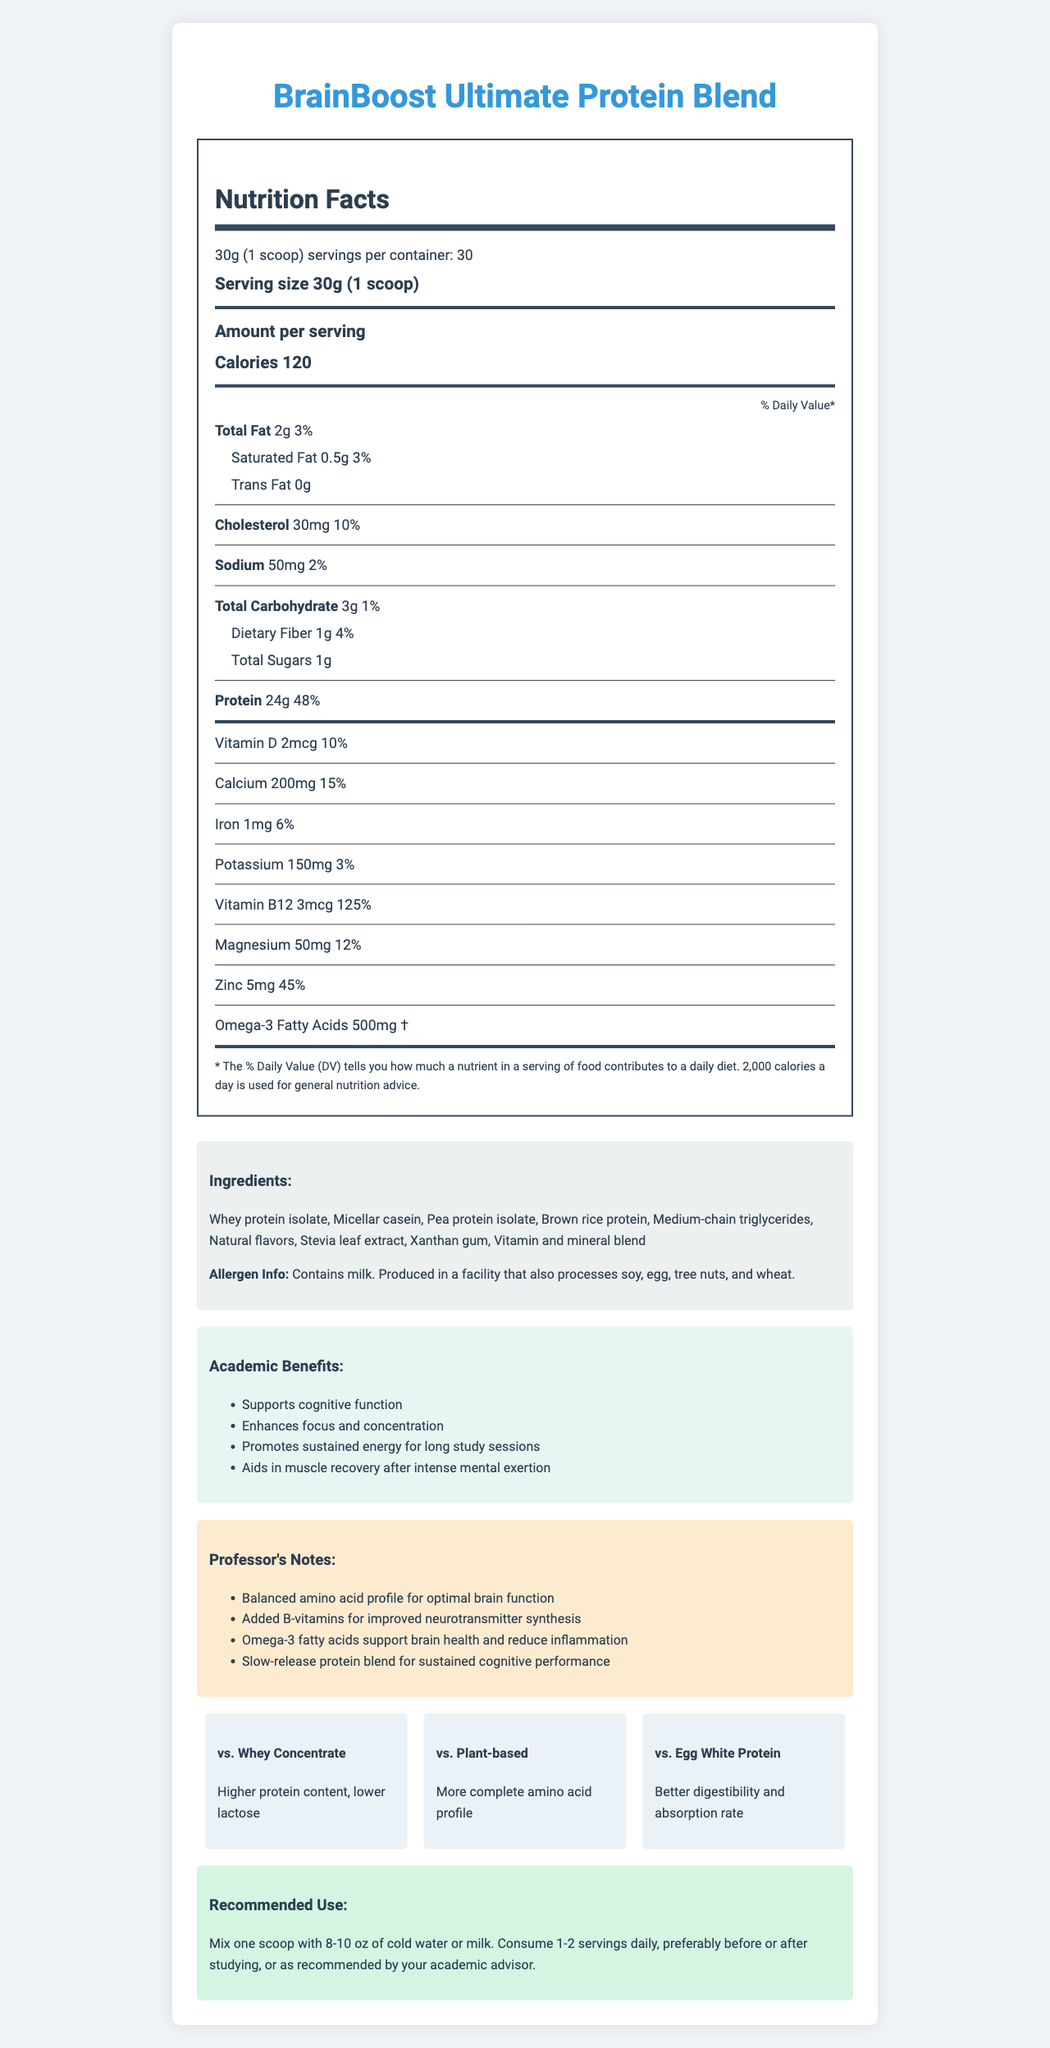what is the serving size of BrainBoost Ultimate Protein Blend? The document states the serving size as "30g (1 scoop)".
Answer: 30g (1 scoop) how many calories are in one serving of BrainBoost Ultimate Protein Blend? The document lists the calories per serving as 120.
Answer: 120 calories which protein supplement has higher protein content than whey concentrate? A. BrainBoost Ultimate Protein Blend B. Plant-based proteins C. Egg White Protein The document mentions that BrainBoost Ultimate Protein Blend has a higher protein content compared to whey concentrate.
Answer: A is BrainBoost Ultimate Protein Blend suitable for someone avoiding milk? The allergen info states that it contains milk.
Answer: No how much protein does one serving of BrainBoost Ultimate Protein Blend provide? The protein amount per serving is given as 24g.
Answer: 24g what are the academic benefits of BrainBoost Ultimate Protein Blend? The section on academic benefits lists these points explicitly.
Answer: Supports cognitive function, enhances focus and concentration, promotes sustained energy for long study sessions, aids in muscle recovery after intense mental exertion can you list three main ingredients of BrainBoost Ultimate Protein Blend? These are the first three ingredients listed among the ingredients.
Answer: Whey protein isolate, Micellar casein, Pea protein isolate what is the percentage of daily value for vitamin B12 in one serving? A. 10% B. 45% C. 125% D. 50% The document specifies that one serving provides 125% of the daily value of vitamin B12.
Answer: C how much omega-3 fatty acids does each serving contain? The amount of omega-3 fatty acids per serving is listed as 500mg.
Answer: 500mg can you determine if the BrainBoost will exactly meet my daily vitamin D needs? The document shows it provides 10% of the daily value, but without knowing individual requirements, it's uncertain if it meets daily needs.
Answer: No how does BrainBoost Ultimate Protein Blend compare with egg white protein in terms of digestibility and absorption? The document states that BrainBoost Ultimate Protein Blend has better digestibility and absorption rate compared to egg white protein.
Answer: Better digestibility and absorption rate does BrainBoost Ultimate Protein Blend have any dietary fiber? The label indicates it has 1g of dietary fiber per serving, which is 4% of the daily value.
Answer: Yes summarize the entire document and its main purposes. The document is a comprehensive description of the BrainBoost Ultimate Protein Blend, detailing its nutritional content, benefits for academic performance, ingredients, allergen information, comparisons to other proteins, and recommended usage. It emphasizes the supplement’s cognitive benefits and features a professor's endorsement.
Answer: BrainBoost Ultimate Protein Blend is a protein supplement designed to support cognitive function and academic performance. It provides 24g of protein per serving, with a mix of whey protein isolate, micellar casein, pea protein isolate, and other ingredients. The supplement offers additional benefits such as enhanced focus, sustained energy, and muscle recovery. It is enriched with vitamins and minerals, including vitamin B12, calcium, and omega-3 fatty acids. The product is compared favorably to whey concentrate, plant-based proteins, and egg white protein for its higher protein content, complete amino acid profile, and better digestibility. 